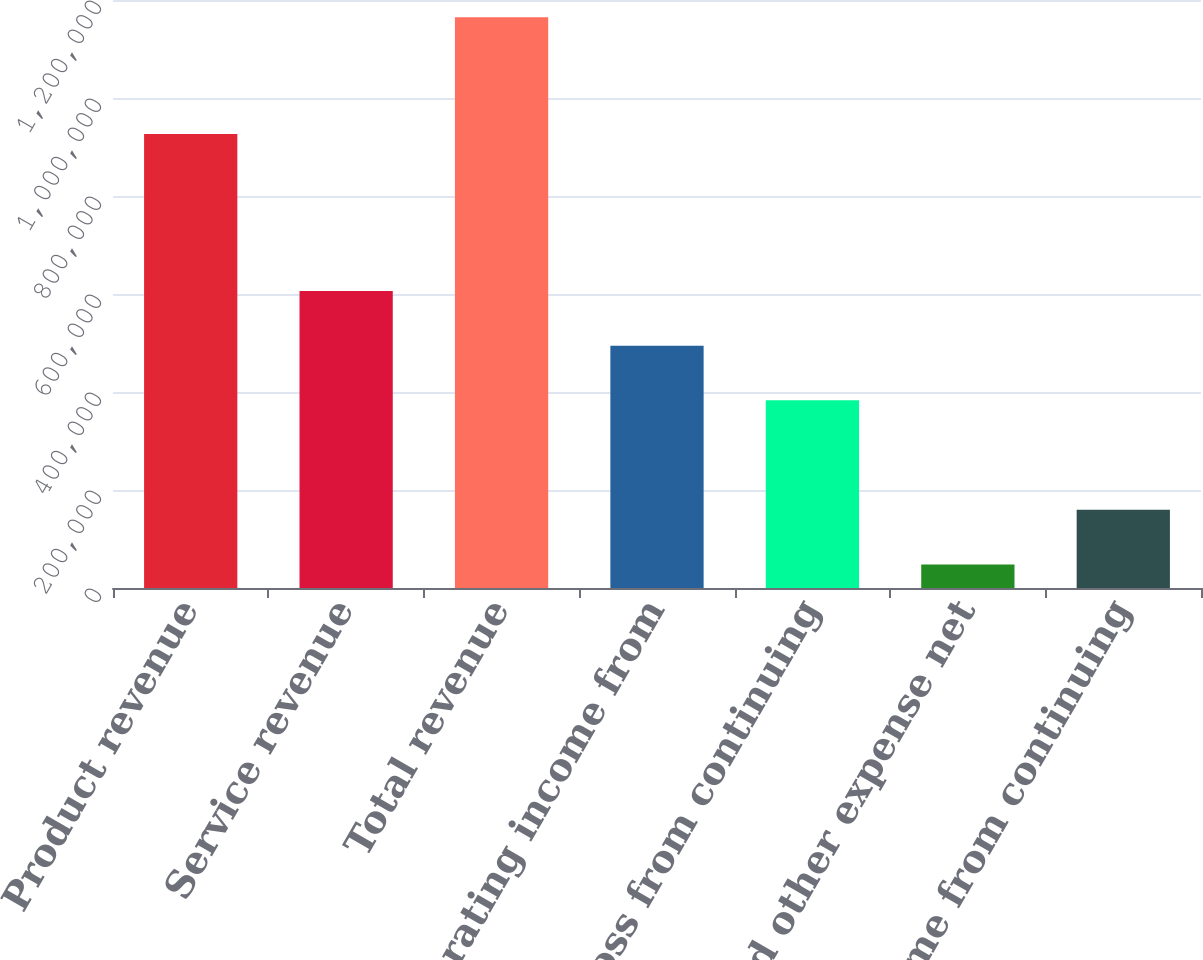Convert chart to OTSL. <chart><loc_0><loc_0><loc_500><loc_500><bar_chart><fcel>Product revenue<fcel>Service revenue<fcel>Total revenue<fcel>Operating income from<fcel>Operating loss from continuing<fcel>Interest and other expense net<fcel>Income from continuing<nl><fcel>926733<fcel>606290<fcel>1.16462e+06<fcel>494624<fcel>382957<fcel>47956<fcel>159623<nl></chart> 